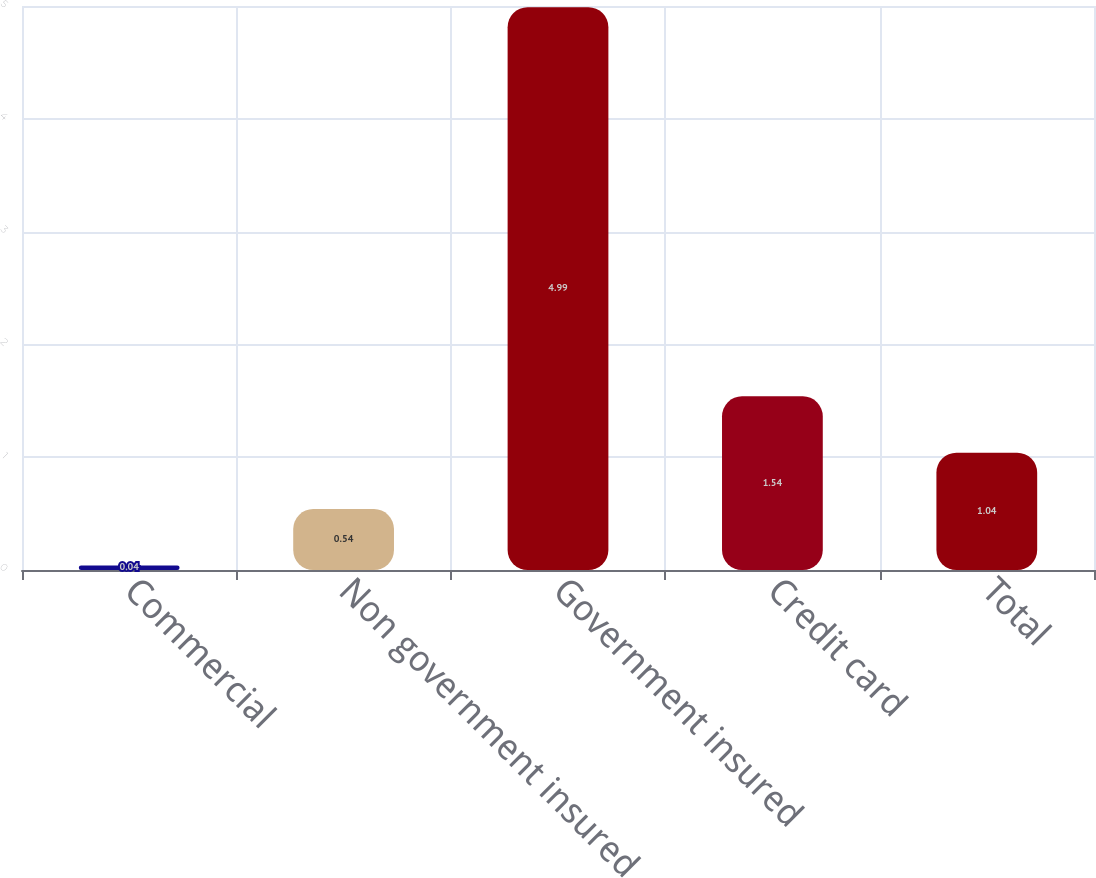Convert chart. <chart><loc_0><loc_0><loc_500><loc_500><bar_chart><fcel>Commercial<fcel>Non government insured<fcel>Government insured<fcel>Credit card<fcel>Total<nl><fcel>0.04<fcel>0.54<fcel>4.99<fcel>1.54<fcel>1.04<nl></chart> 